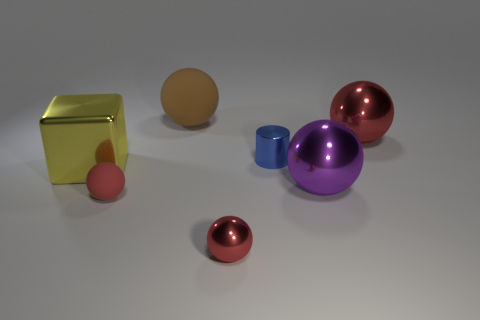There is a ball that is both to the right of the small blue shiny cylinder and behind the big cube; what is it made of?
Provide a short and direct response. Metal. How many spheres are either large purple shiny things or red rubber objects?
Give a very brief answer. 2. There is a brown thing that is the same shape as the purple metallic thing; what material is it?
Your response must be concise. Rubber. What size is the blue object that is the same material as the purple thing?
Provide a short and direct response. Small. There is a large metal thing in front of the large yellow metallic object; is its shape the same as the small metal object that is behind the yellow object?
Give a very brief answer. No. What is the color of the cylinder that is made of the same material as the big purple sphere?
Make the answer very short. Blue. There is a metallic thing in front of the small red matte sphere; is its size the same as the matte thing behind the small matte thing?
Provide a short and direct response. No. There is a big metal object that is both right of the metal block and in front of the tiny cylinder; what shape is it?
Give a very brief answer. Sphere. Is there a small sphere that has the same material as the small blue cylinder?
Your answer should be very brief. Yes. There is a tiny object that is the same color as the small metallic sphere; what material is it?
Your answer should be very brief. Rubber. 